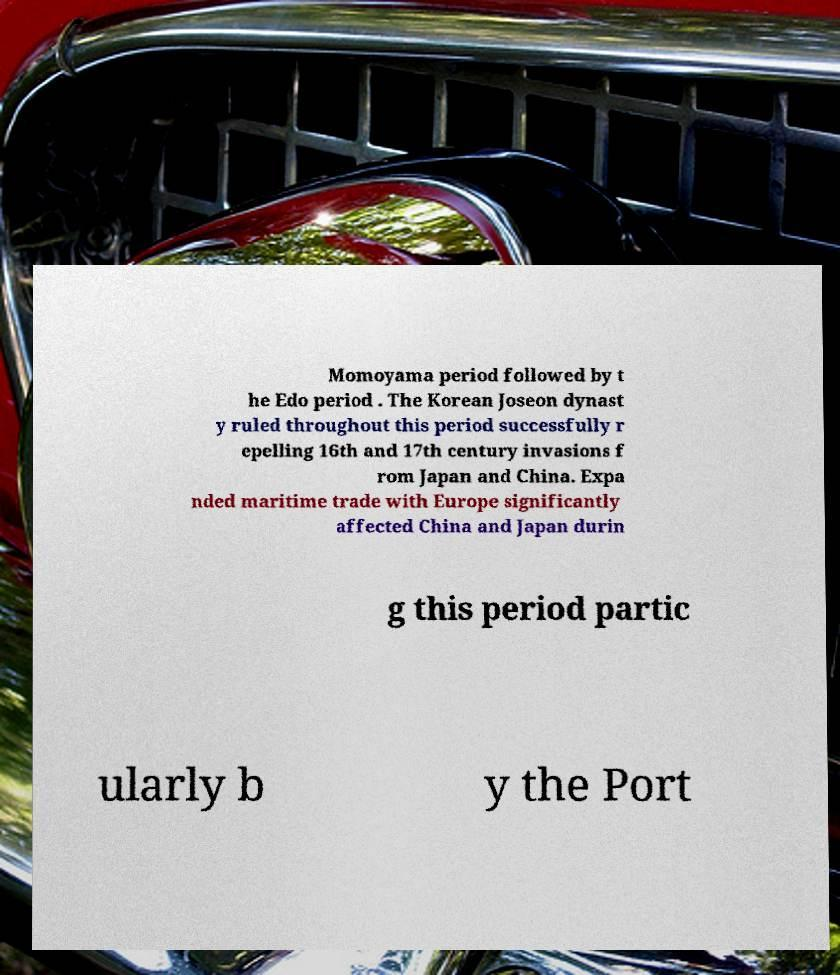For documentation purposes, I need the text within this image transcribed. Could you provide that? Momoyama period followed by t he Edo period . The Korean Joseon dynast y ruled throughout this period successfully r epelling 16th and 17th century invasions f rom Japan and China. Expa nded maritime trade with Europe significantly affected China and Japan durin g this period partic ularly b y the Port 